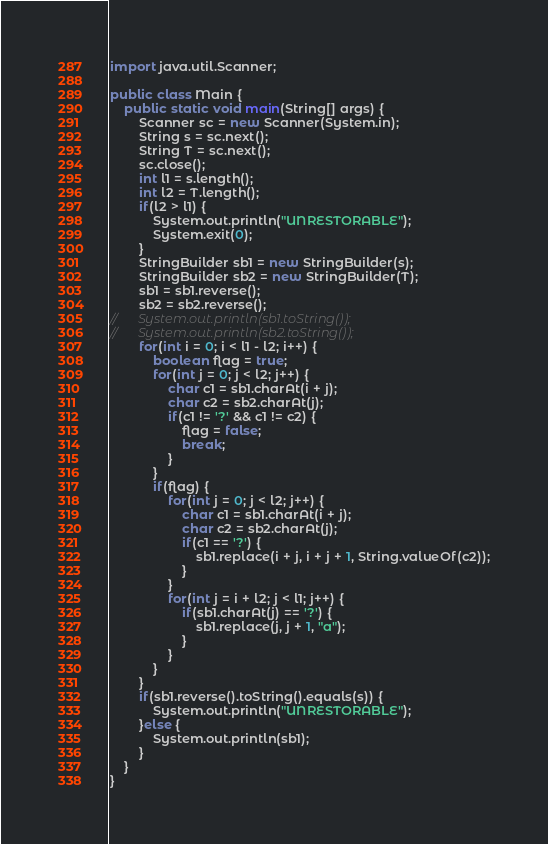<code> <loc_0><loc_0><loc_500><loc_500><_Java_>import java.util.Scanner;

public class Main {
	public static void main(String[] args) {
		Scanner sc = new Scanner(System.in);
		String s = sc.next();
		String T = sc.next();
		sc.close();
		int l1 = s.length();
		int l2 = T.length();
		if(l2 > l1) {
			System.out.println("UNRESTORABLE");
			System.exit(0);
		}
		StringBuilder sb1 = new StringBuilder(s);
		StringBuilder sb2 = new StringBuilder(T);
		sb1 = sb1.reverse();
		sb2 = sb2.reverse();
//		System.out.println(sb1.toString());
//		System.out.println(sb2.toString());
		for(int i = 0; i < l1 - l2; i++) {
			boolean flag = true;
			for(int j = 0; j < l2; j++) {
				char c1 = sb1.charAt(i + j);
				char c2 = sb2.charAt(j);
				if(c1 != '?' && c1 != c2) {
					flag = false;
					break;
				}
			}
			if(flag) {
				for(int j = 0; j < l2; j++) {
					char c1 = sb1.charAt(i + j);
					char c2 = sb2.charAt(j);
					if(c1 == '?') {
						sb1.replace(i + j, i + j + 1, String.valueOf(c2));
					}
				}
				for(int j = i + l2; j < l1; j++) {
					if(sb1.charAt(j) == '?') {
						sb1.replace(j, j + 1, "a");
					}
				}
			}
		}
		if(sb1.reverse().toString().equals(s)) {
			System.out.println("UNRESTORABLE");
		}else {
			System.out.println(sb1);
		}
	}
}</code> 